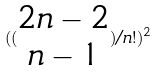<formula> <loc_0><loc_0><loc_500><loc_500>( ( \begin{matrix} 2 n - 2 \\ n - 1 \end{matrix} ) / n ! ) ^ { 2 }</formula> 